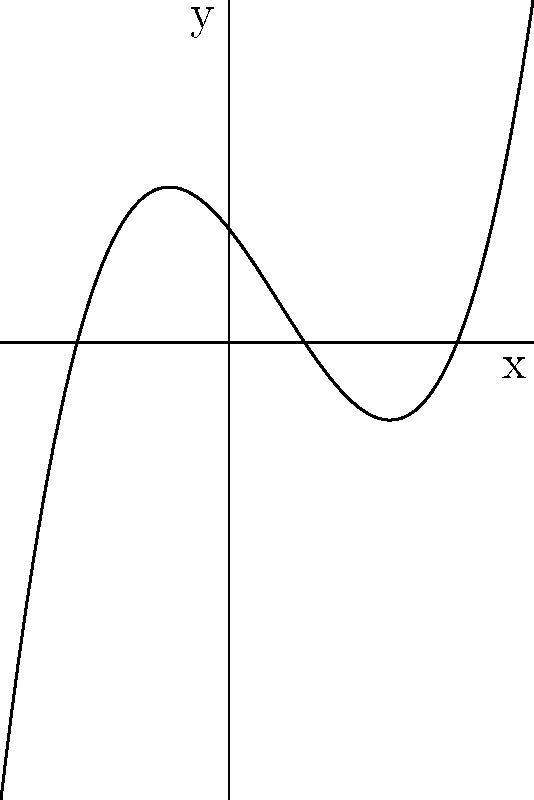As a motivational speaker who has overcome mental health struggles, you often use metaphors to inspire athletes. Consider the graph of a polynomial function that represents the journey of overcoming challenges. The x-axis represents time, and the y-axis represents personal growth. Given the graph, determine the roots of this polynomial function and explain what they might symbolize in an athlete's journey. To find the roots of the polynomial function, we need to identify where the graph crosses the x-axis. These points represent where $y = 0$.

Step 1: Observe the graph and locate the x-intercepts.
We can see that the graph crosses the x-axis at three points.

Step 2: Determine the x-coordinates of these intercepts.
From the graph, we can see that the roots are at:
- $x = -2$
- $x = 1$
- $x = 3$

Step 3: Interpret the meaning of these roots in the context of an athlete's journey:
- $x = -2$ could represent the starting point, perhaps when an athlete first faces a significant challenge or mental health struggle.
- $x = 1$ might symbolize a turning point in their journey, where they begin to see progress in overcoming their struggles.
- $x = 3$ could represent the point where they have fully overcome their challenges and achieved significant personal growth.

The polynomial function can be written in the form:

$f(x) = a(x+2)(x-1)(x-3)$

where $a$ is a constant that determines the vertical stretch of the graph.

Step 4: Verify that these roots make sense with the graph's behavior.
The graph indeed crosses the x-axis at these three points, confirming our analysis.
Answer: The roots are $x = -2$, $x = 1$, and $x = 3$. 